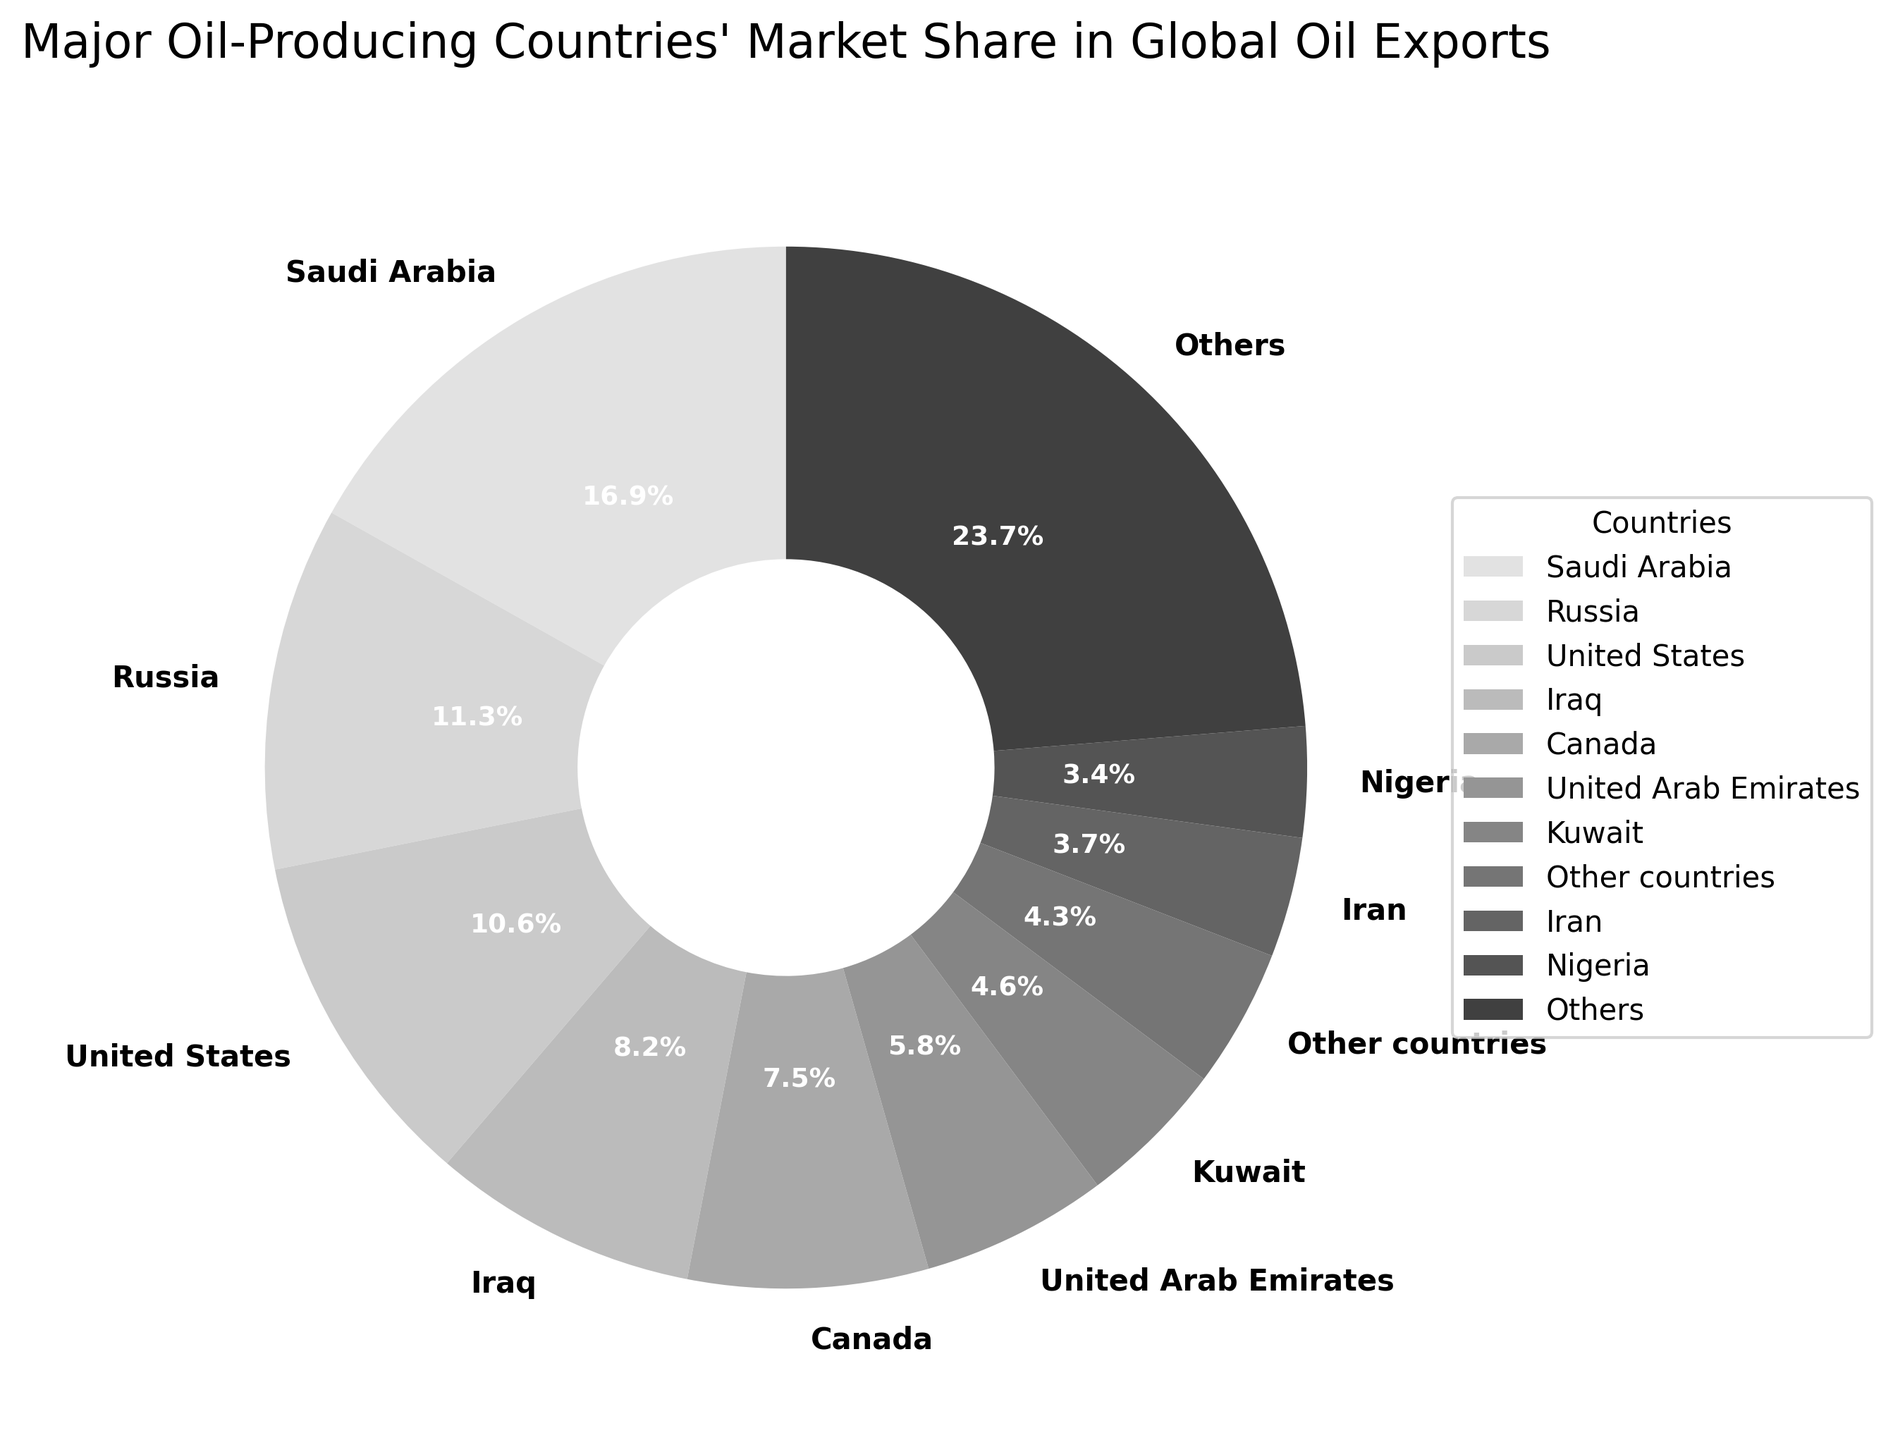Which country has the largest market share of global oil exports? The pie chart indicates the percentage of market share for each country. By examining the segment sizes, Saudi Arabia has the largest share at 17.2%.
Answer: Saudi Arabia What is the combined market share of the top three oil-producing countries? The top three countries are Saudi Arabia (17.2%), Russia (11.5%), and the United States (10.8%). Adding these shares: 17.2 + 11.5 + 10.8 = 39.5%.
Answer: 39.5% How does the market share of Canada compare to that of Iraq? Canada's market share is 7.6%, while Iraq's market share is 8.4%. By comparing these values, Iraq's share is slightly larger.
Answer: Iraq What is the total market share of countries that have less than 5% share each? The countries with less than 5% share are Iran (3.8%), Nigeria (3.5%), Kazakhstan (3.2%), Norway (3.0%), Brazil (2.8%), Angola (2.5%), Libya (2.3%), Mexico (2.1%), Venezuela (1.9%), Algeria (1.8%), Oman (1.7%), United Kingdom (1.5%), and Qatar (1.4%). Summing these shares: 3.8 + 3.5 + 3.2 + 3 + 2.8 + 2.5 + 2.3 + 2.1 + 1.9 + 1.8 + 1.7 + 1.5 + 1.4 = 34.5%.
Answer: 34.5% What percentage of the market share does "Others" represent? The pie chart includes a segment labeled "Others", which represents the combined market share of countries not listed in the top ten. The value provided is 4.4%.
Answer: 4.4% What is the difference in market share between the United Arab Emirates and Kuwait? The United Arab Emirates has a market share of 5.9% and Kuwait has 4.7%. The difference is 5.9 - 4.7 = 1.2%.
Answer: 1.2% Among the top ten countries, which one has the smallest market share, and what is its value? The countries in the top ten are listed in descending order, with Kazakhstan being the last at 3.2%.
Answer: Kazakhstan, 3.2% If we group the United Arab Emirates, Kuwait, and Iran together, what would be their combined market share? The market shares for the United Arab Emirates, Kuwait, and Iran are 5.9%, 4.7%, and 3.8%, respectively. Summing these values: 5.9 + 4.7 + 3.8 = 14.4%.
Answer: 14.4% Which segment uses the darkest shade in the pie chart and what is the corresponding country? The pie chart uses a grayscale color scheme where the largest segment, Saudi Arabia, with 17.2% would use the darkest shade.
Answer: Saudi Arabia 